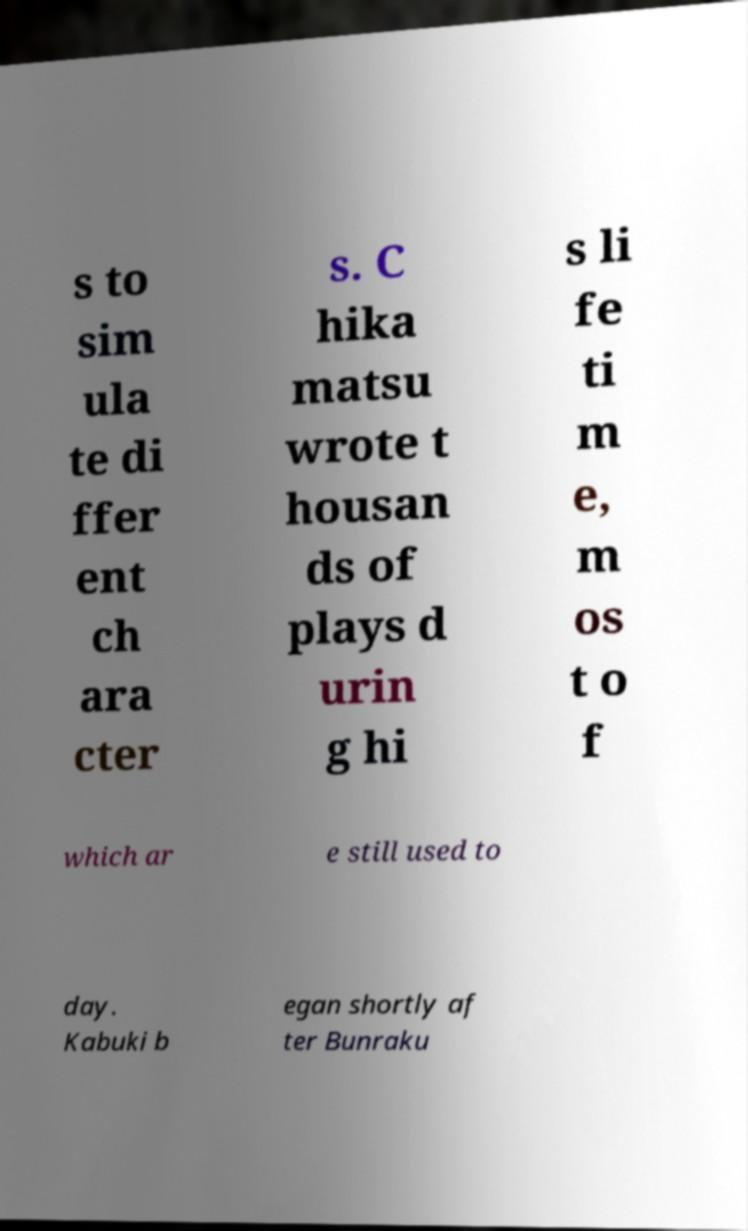What messages or text are displayed in this image? I need them in a readable, typed format. s to sim ula te di ffer ent ch ara cter s. C hika matsu wrote t housan ds of plays d urin g hi s li fe ti m e, m os t o f which ar e still used to day. Kabuki b egan shortly af ter Bunraku 